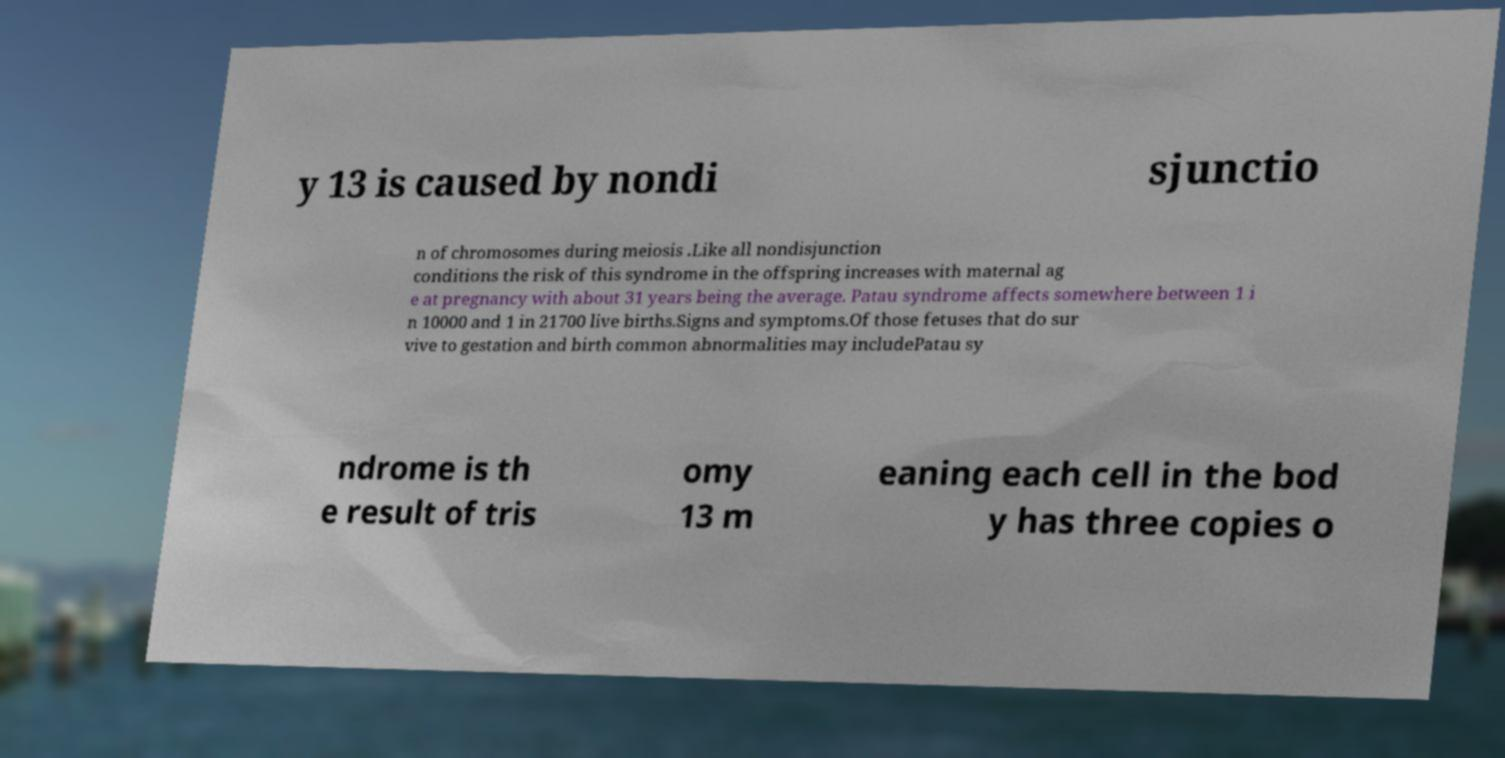There's text embedded in this image that I need extracted. Can you transcribe it verbatim? y 13 is caused by nondi sjunctio n of chromosomes during meiosis .Like all nondisjunction conditions the risk of this syndrome in the offspring increases with maternal ag e at pregnancy with about 31 years being the average. Patau syndrome affects somewhere between 1 i n 10000 and 1 in 21700 live births.Signs and symptoms.Of those fetuses that do sur vive to gestation and birth common abnormalities may includePatau sy ndrome is th e result of tris omy 13 m eaning each cell in the bod y has three copies o 